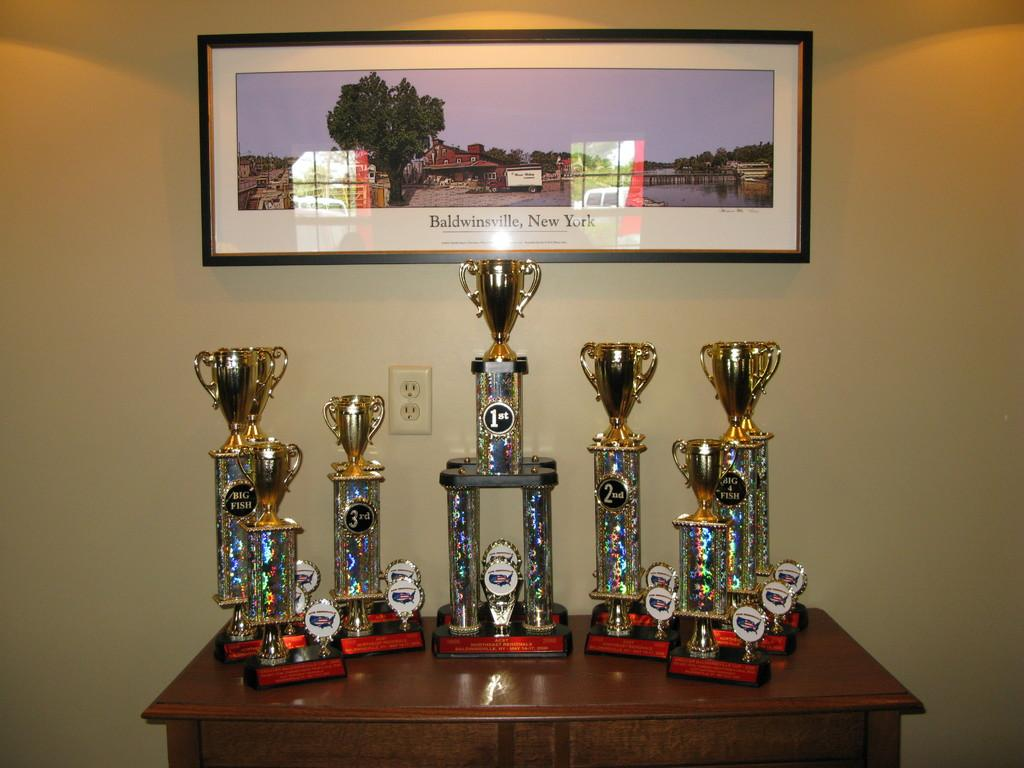<image>
Summarize the visual content of the image. table with six trophies, 2 labeled big fish below a wide picture of baldwinsville, new york 